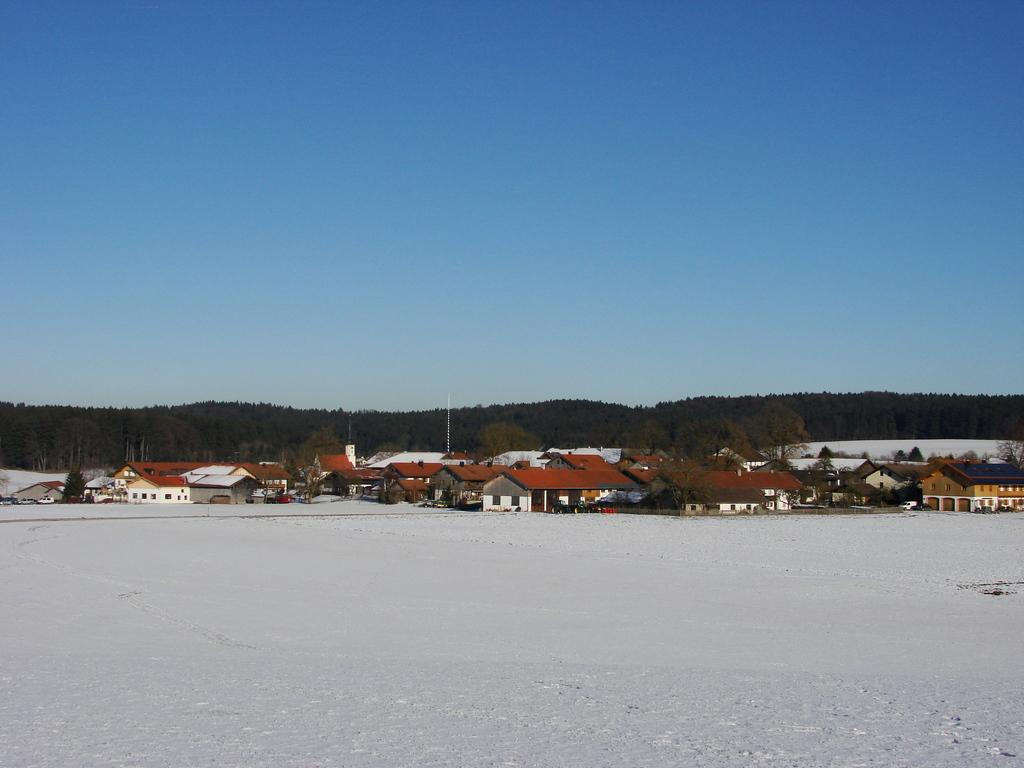What type of weather condition is depicted in the image? There is snow on the surface in the image, indicating a snowy or wintry condition. What can be seen in the background of the image? There are buildings, trees, and a tower in the background of the image. What is visible at the top of the image? The sky is visible at the top of the image. Where is the cactus located in the image? There is no cactus present in the image. What type of toothpaste is used to clean the snow in the image? There is no toothpaste mentioned or implied in the image; it is a natural snowy scene. 